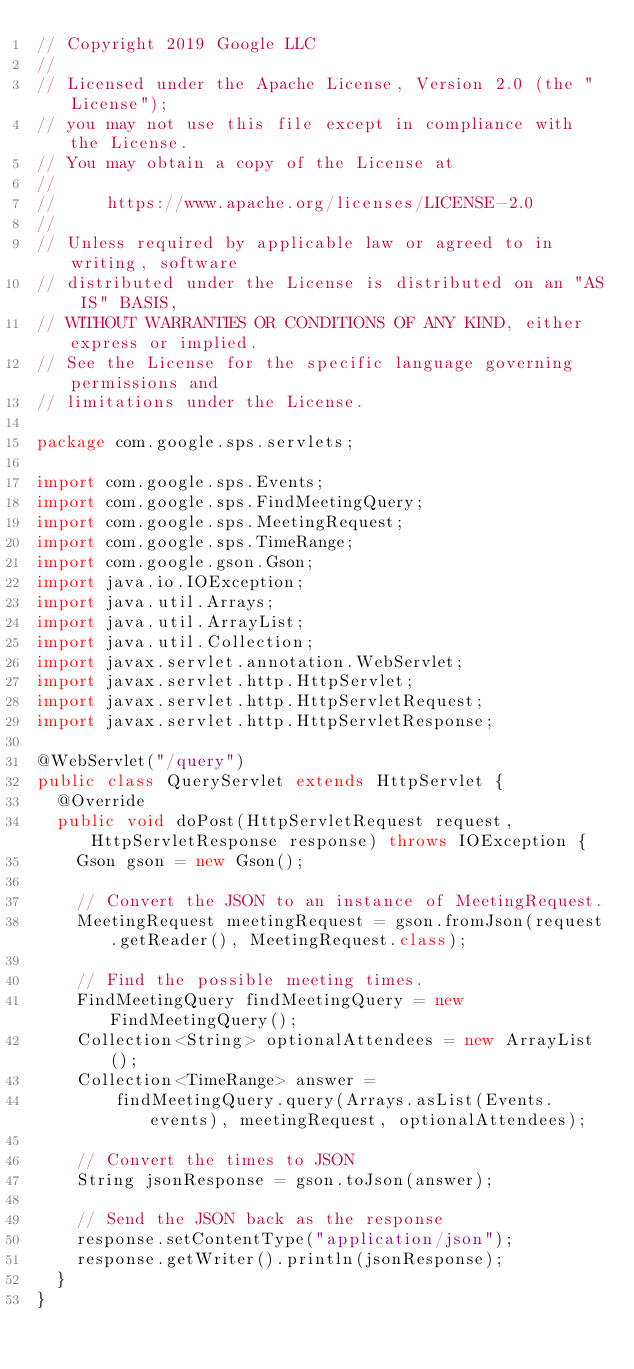Convert code to text. <code><loc_0><loc_0><loc_500><loc_500><_Java_>// Copyright 2019 Google LLC
//
// Licensed under the Apache License, Version 2.0 (the "License");
// you may not use this file except in compliance with the License.
// You may obtain a copy of the License at
//
//     https://www.apache.org/licenses/LICENSE-2.0
//
// Unless required by applicable law or agreed to in writing, software
// distributed under the License is distributed on an "AS IS" BASIS,
// WITHOUT WARRANTIES OR CONDITIONS OF ANY KIND, either express or implied.
// See the License for the specific language governing permissions and
// limitations under the License.

package com.google.sps.servlets;

import com.google.sps.Events;
import com.google.sps.FindMeetingQuery;
import com.google.sps.MeetingRequest;
import com.google.sps.TimeRange;
import com.google.gson.Gson;
import java.io.IOException;
import java.util.Arrays;
import java.util.ArrayList;
import java.util.Collection;
import javax.servlet.annotation.WebServlet;
import javax.servlet.http.HttpServlet;
import javax.servlet.http.HttpServletRequest;
import javax.servlet.http.HttpServletResponse;

@WebServlet("/query")
public class QueryServlet extends HttpServlet {
  @Override
  public void doPost(HttpServletRequest request, HttpServletResponse response) throws IOException {
    Gson gson = new Gson();

    // Convert the JSON to an instance of MeetingRequest.
    MeetingRequest meetingRequest = gson.fromJson(request.getReader(), MeetingRequest.class);

    // Find the possible meeting times.
    FindMeetingQuery findMeetingQuery = new FindMeetingQuery();
    Collection<String> optionalAttendees = new ArrayList();
    Collection<TimeRange> answer =
        findMeetingQuery.query(Arrays.asList(Events.events), meetingRequest, optionalAttendees);

    // Convert the times to JSON
    String jsonResponse = gson.toJson(answer);

    // Send the JSON back as the response
    response.setContentType("application/json");
    response.getWriter().println(jsonResponse);
  }
}
</code> 